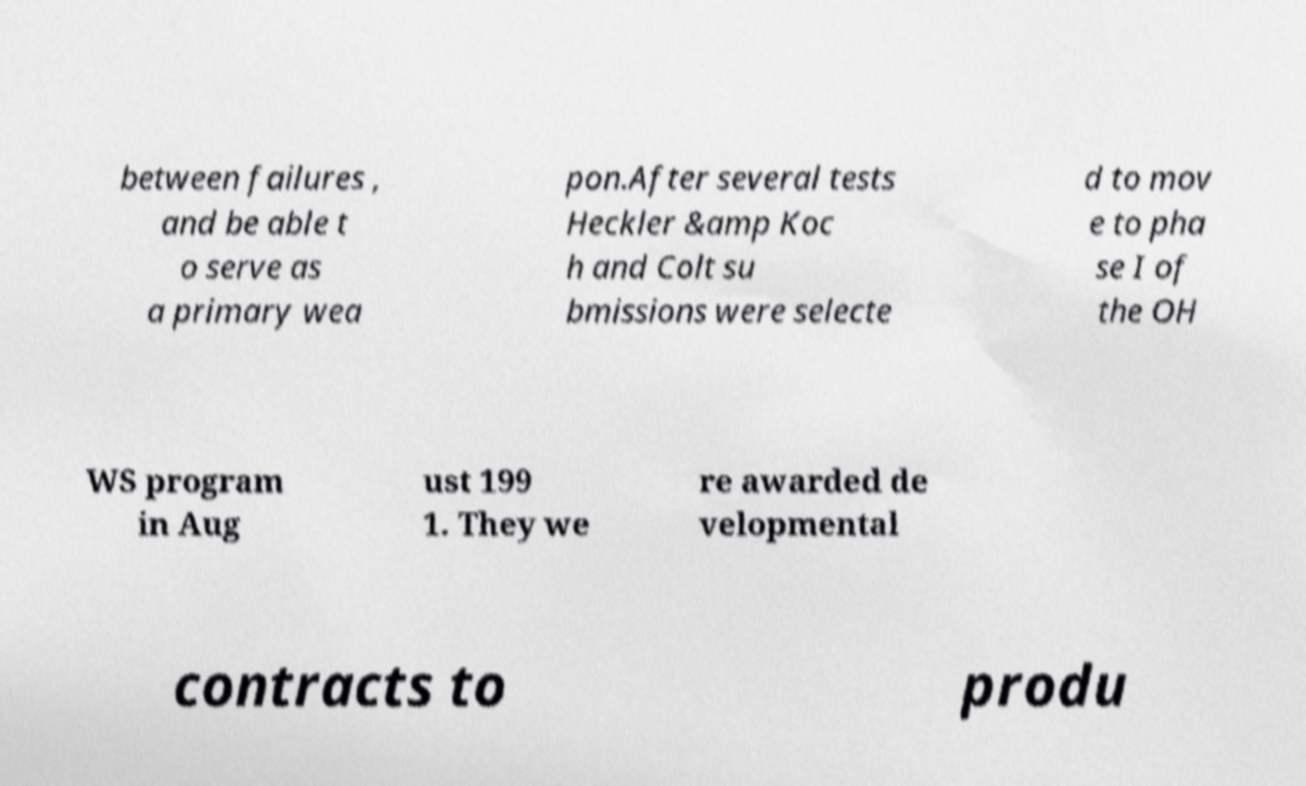Could you assist in decoding the text presented in this image and type it out clearly? between failures , and be able t o serve as a primary wea pon.After several tests Heckler &amp Koc h and Colt su bmissions were selecte d to mov e to pha se I of the OH WS program in Aug ust 199 1. They we re awarded de velopmental contracts to produ 